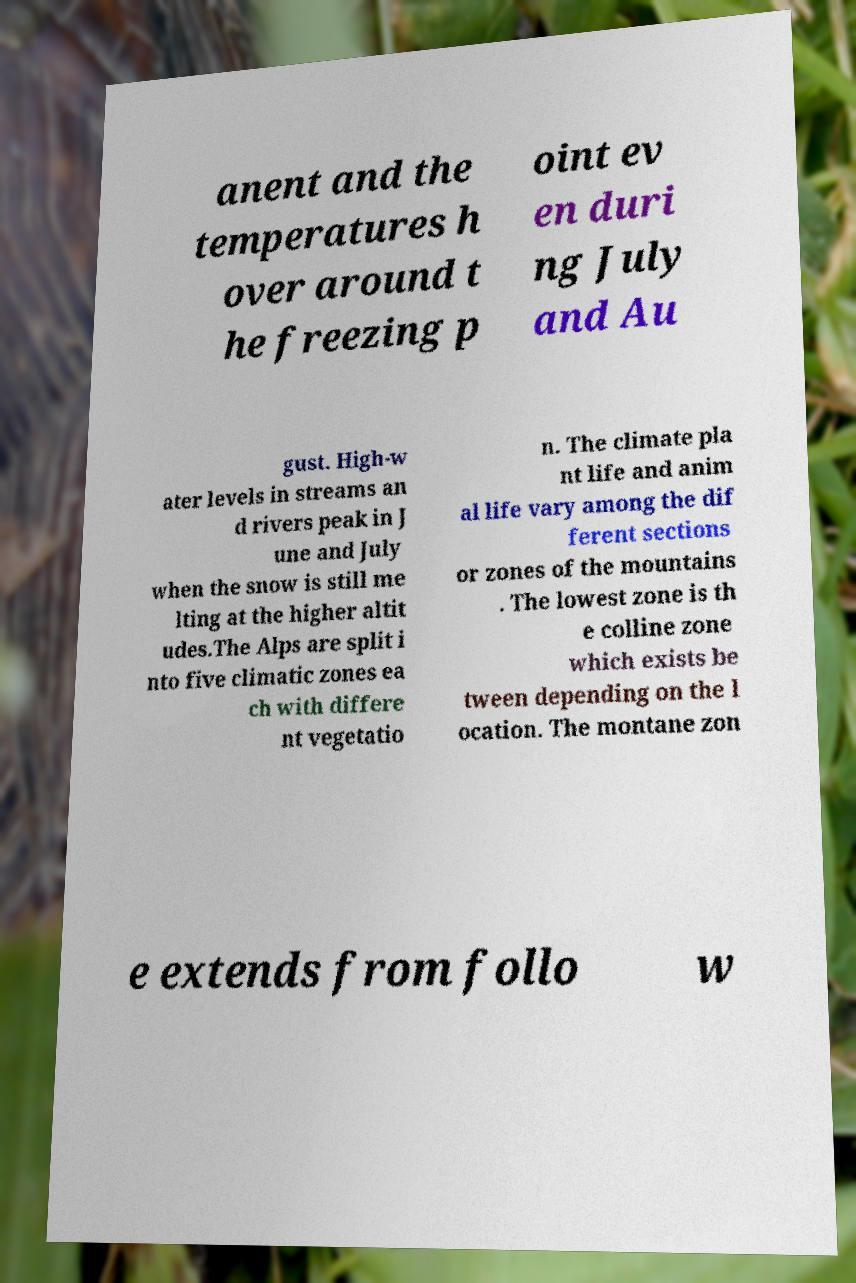Please identify and transcribe the text found in this image. anent and the temperatures h over around t he freezing p oint ev en duri ng July and Au gust. High-w ater levels in streams an d rivers peak in J une and July when the snow is still me lting at the higher altit udes.The Alps are split i nto five climatic zones ea ch with differe nt vegetatio n. The climate pla nt life and anim al life vary among the dif ferent sections or zones of the mountains . The lowest zone is th e colline zone which exists be tween depending on the l ocation. The montane zon e extends from follo w 